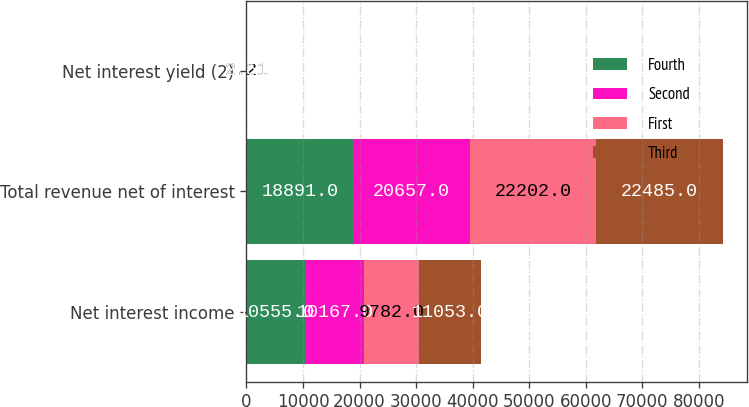Convert chart. <chart><loc_0><loc_0><loc_500><loc_500><stacked_bar_chart><ecel><fcel>Net interest income<fcel>Total revenue net of interest<fcel>Net interest yield (2)<nl><fcel>Fourth<fcel>10555<fcel>18891<fcel>2.35<nl><fcel>Second<fcel>10167<fcel>20657<fcel>2.32<nl><fcel>First<fcel>9782<fcel>22202<fcel>2.21<nl><fcel>Third<fcel>11053<fcel>22485<fcel>2.51<nl></chart> 